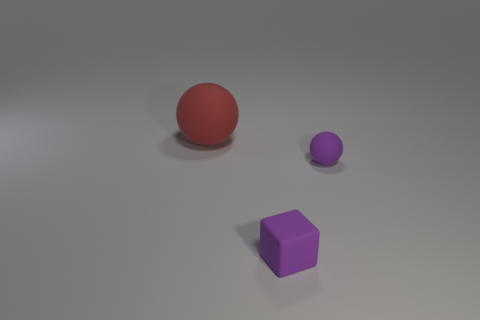Subtract all cyan balls. Subtract all yellow cubes. How many balls are left? 2 Add 1 purple rubber things. How many objects exist? 4 Subtract all blocks. How many objects are left? 2 Subtract 0 purple cylinders. How many objects are left? 3 Subtract all rubber blocks. Subtract all large things. How many objects are left? 1 Add 3 big balls. How many big balls are left? 4 Add 1 large spheres. How many large spheres exist? 2 